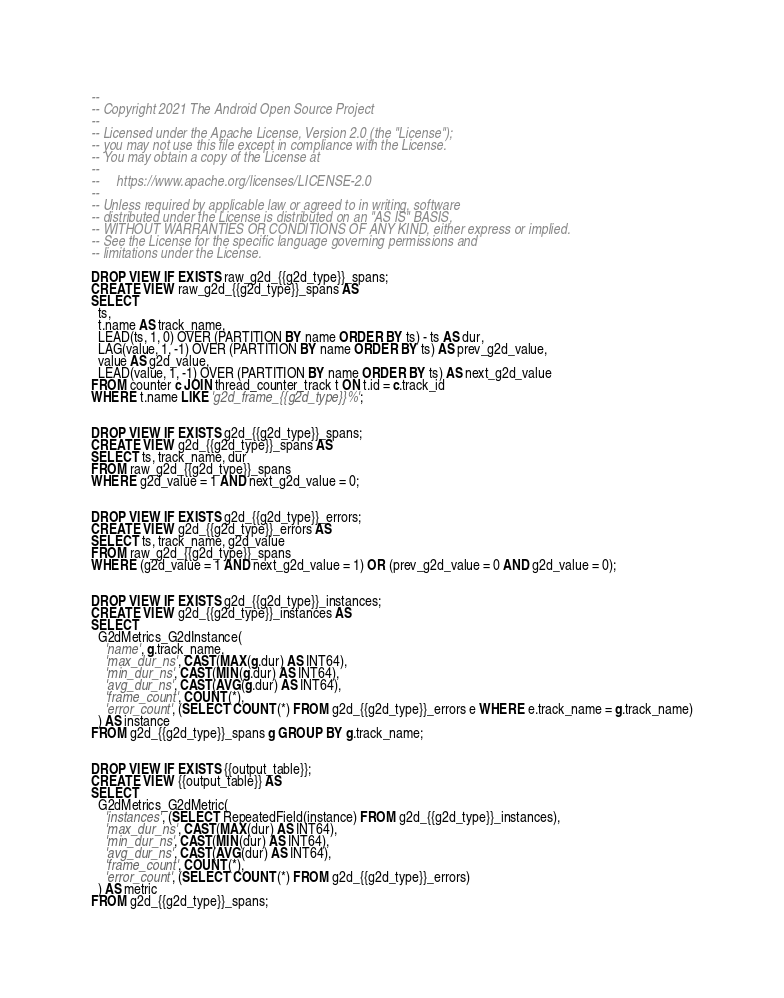<code> <loc_0><loc_0><loc_500><loc_500><_SQL_>--
-- Copyright 2021 The Android Open Source Project
--
-- Licensed under the Apache License, Version 2.0 (the "License");
-- you may not use this file except in compliance with the License.
-- You may obtain a copy of the License at
--
--     https://www.apache.org/licenses/LICENSE-2.0
--
-- Unless required by applicable law or agreed to in writing, software
-- distributed under the License is distributed on an "AS IS" BASIS,
-- WITHOUT WARRANTIES OR CONDITIONS OF ANY KIND, either express or implied.
-- See the License for the specific language governing permissions and
-- limitations under the License.

DROP VIEW IF EXISTS raw_g2d_{{g2d_type}}_spans;
CREATE VIEW raw_g2d_{{g2d_type}}_spans AS
SELECT
  ts,
  t.name AS track_name,
  LEAD(ts, 1, 0) OVER (PARTITION BY name ORDER BY ts) - ts AS dur,
  LAG(value, 1, -1) OVER (PARTITION BY name ORDER BY ts) AS prev_g2d_value,
  value AS g2d_value,
  LEAD(value, 1, -1) OVER (PARTITION BY name ORDER BY ts) AS next_g2d_value
FROM counter c JOIN thread_counter_track t ON t.id = c.track_id
WHERE t.name LIKE 'g2d_frame_{{g2d_type}}%';


DROP VIEW IF EXISTS g2d_{{g2d_type}}_spans;
CREATE VIEW g2d_{{g2d_type}}_spans AS
SELECT ts, track_name, dur
FROM raw_g2d_{{g2d_type}}_spans
WHERE g2d_value = 1 AND next_g2d_value = 0;


DROP VIEW IF EXISTS g2d_{{g2d_type}}_errors;
CREATE VIEW g2d_{{g2d_type}}_errors AS
SELECT ts, track_name, g2d_value
FROM raw_g2d_{{g2d_type}}_spans
WHERE (g2d_value = 1 AND next_g2d_value = 1) OR (prev_g2d_value = 0 AND g2d_value = 0);


DROP VIEW IF EXISTS g2d_{{g2d_type}}_instances;
CREATE VIEW g2d_{{g2d_type}}_instances AS
SELECT
  G2dMetrics_G2dInstance(
    'name', g.track_name,
    'max_dur_ns', CAST(MAX(g.dur) AS INT64),
    'min_dur_ns', CAST(MIN(g.dur) AS INT64),
    'avg_dur_ns', CAST(AVG(g.dur) AS INT64),
    'frame_count', COUNT(*),
    'error_count', (SELECT COUNT(*) FROM g2d_{{g2d_type}}_errors e WHERE e.track_name = g.track_name)
  ) AS instance
FROM g2d_{{g2d_type}}_spans g GROUP BY g.track_name;


DROP VIEW IF EXISTS {{output_table}};
CREATE VIEW {{output_table}} AS
SELECT
  G2dMetrics_G2dMetric(
    'instances', (SELECT RepeatedField(instance) FROM g2d_{{g2d_type}}_instances),
    'max_dur_ns', CAST(MAX(dur) AS INT64),
    'min_dur_ns', CAST(MIN(dur) AS INT64),
    'avg_dur_ns', CAST(AVG(dur) AS INT64),
    'frame_count', COUNT(*),
    'error_count', (SELECT COUNT(*) FROM g2d_{{g2d_type}}_errors)
  ) AS metric
FROM g2d_{{g2d_type}}_spans;
</code> 